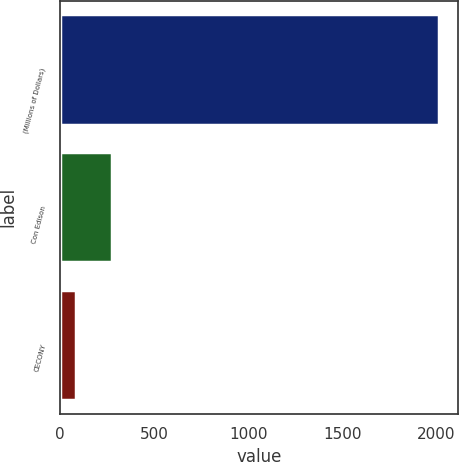<chart> <loc_0><loc_0><loc_500><loc_500><bar_chart><fcel>(Millions of Dollars)<fcel>Con Edison<fcel>CECONY<nl><fcel>2016<fcel>278.1<fcel>85<nl></chart> 